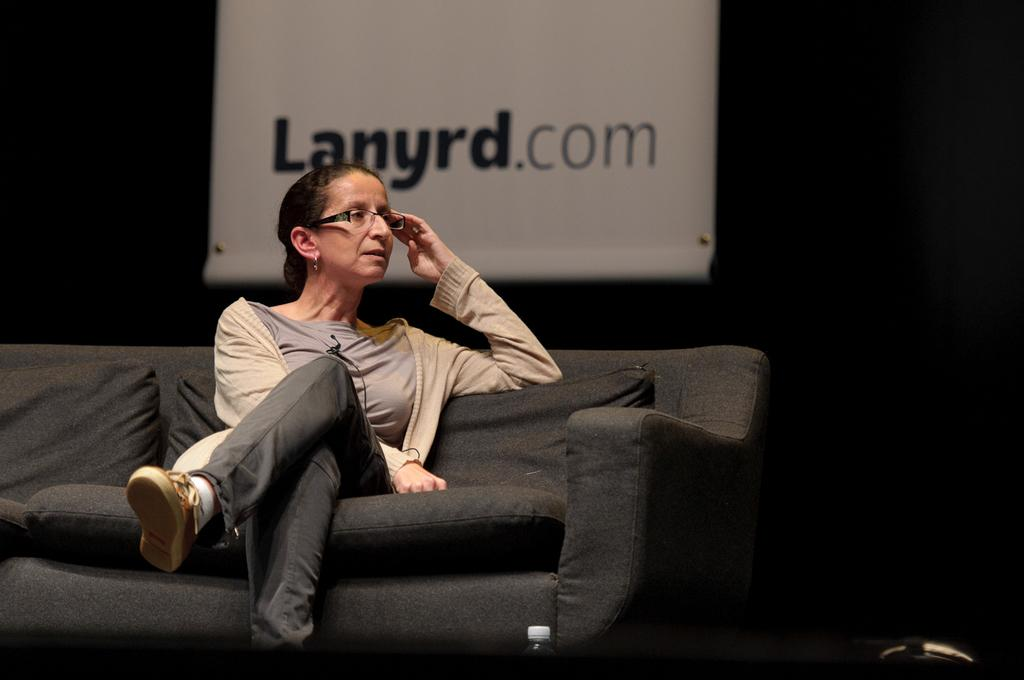Who is present in the image? There is a woman in the image. What is the woman doing in the image? The woman is seated on a sofa. What can be seen in the background of the image? There is a hoarding visible behind the woman. What type of leather is the woman wearing in the image? There is no information about the woman's clothing in the image, so it cannot be determined if she is wearing leather or any other material. 